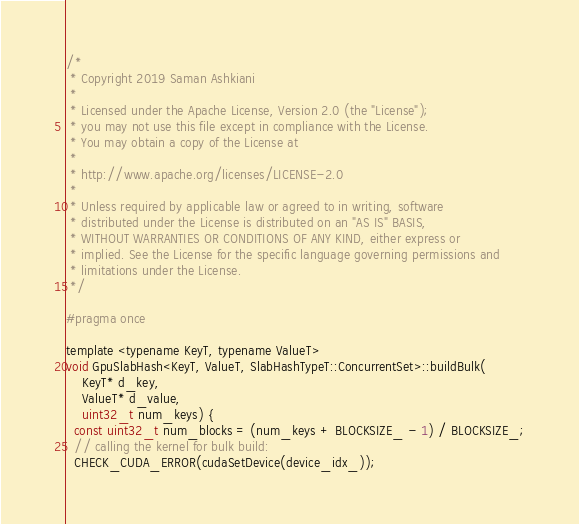<code> <loc_0><loc_0><loc_500><loc_500><_Cuda_>/*
 * Copyright 2019 Saman Ashkiani
 *
 * Licensed under the Apache License, Version 2.0 (the "License");
 * you may not use this file except in compliance with the License.
 * You may obtain a copy of the License at
 *
 * http://www.apache.org/licenses/LICENSE-2.0
 *
 * Unless required by applicable law or agreed to in writing, software
 * distributed under the License is distributed on an "AS IS" BASIS,
 * WITHOUT WARRANTIES OR CONDITIONS OF ANY KIND, either express or
 * implied. See the License for the specific language governing permissions and
 * limitations under the License.
 */

#pragma once

template <typename KeyT, typename ValueT>
void GpuSlabHash<KeyT, ValueT, SlabHashTypeT::ConcurrentSet>::buildBulk(
    KeyT* d_key,
    ValueT* d_value,
    uint32_t num_keys) {
  const uint32_t num_blocks = (num_keys + BLOCKSIZE_ - 1) / BLOCKSIZE_;
  // calling the kernel for bulk build:
  CHECK_CUDA_ERROR(cudaSetDevice(device_idx_));</code> 